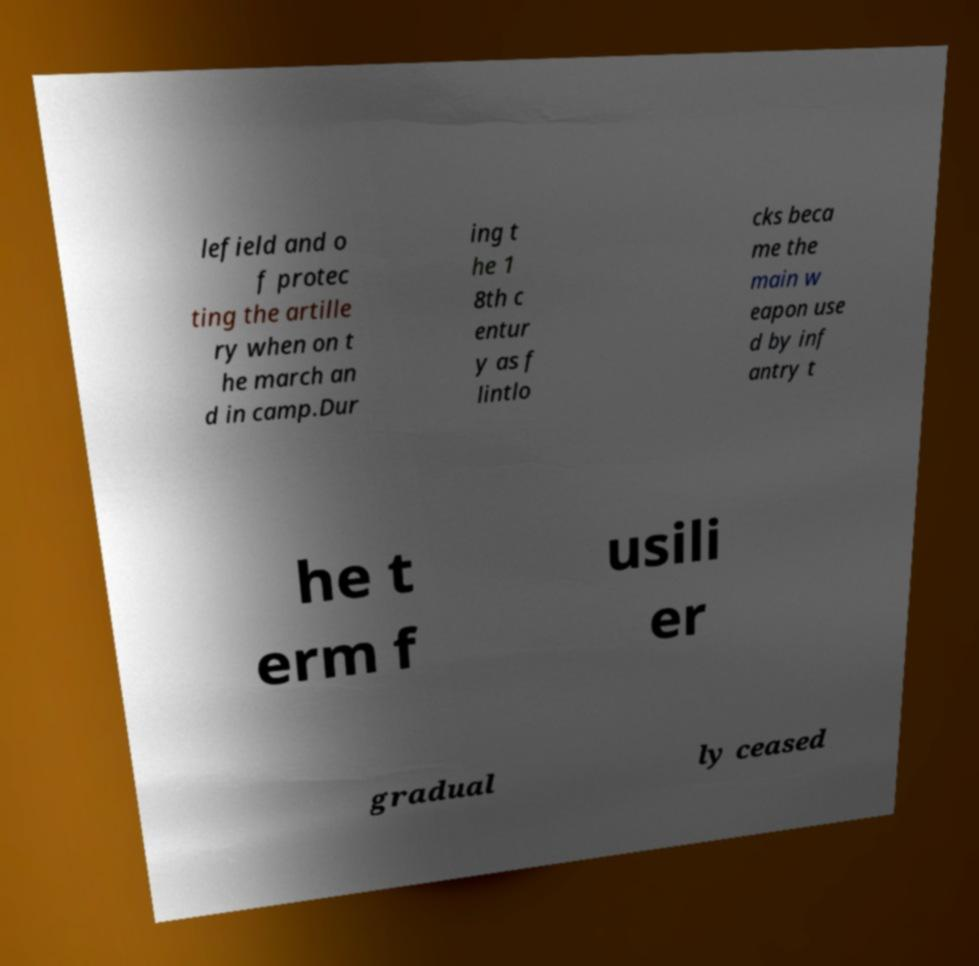Can you accurately transcribe the text from the provided image for me? lefield and o f protec ting the artille ry when on t he march an d in camp.Dur ing t he 1 8th c entur y as f lintlo cks beca me the main w eapon use d by inf antry t he t erm f usili er gradual ly ceased 